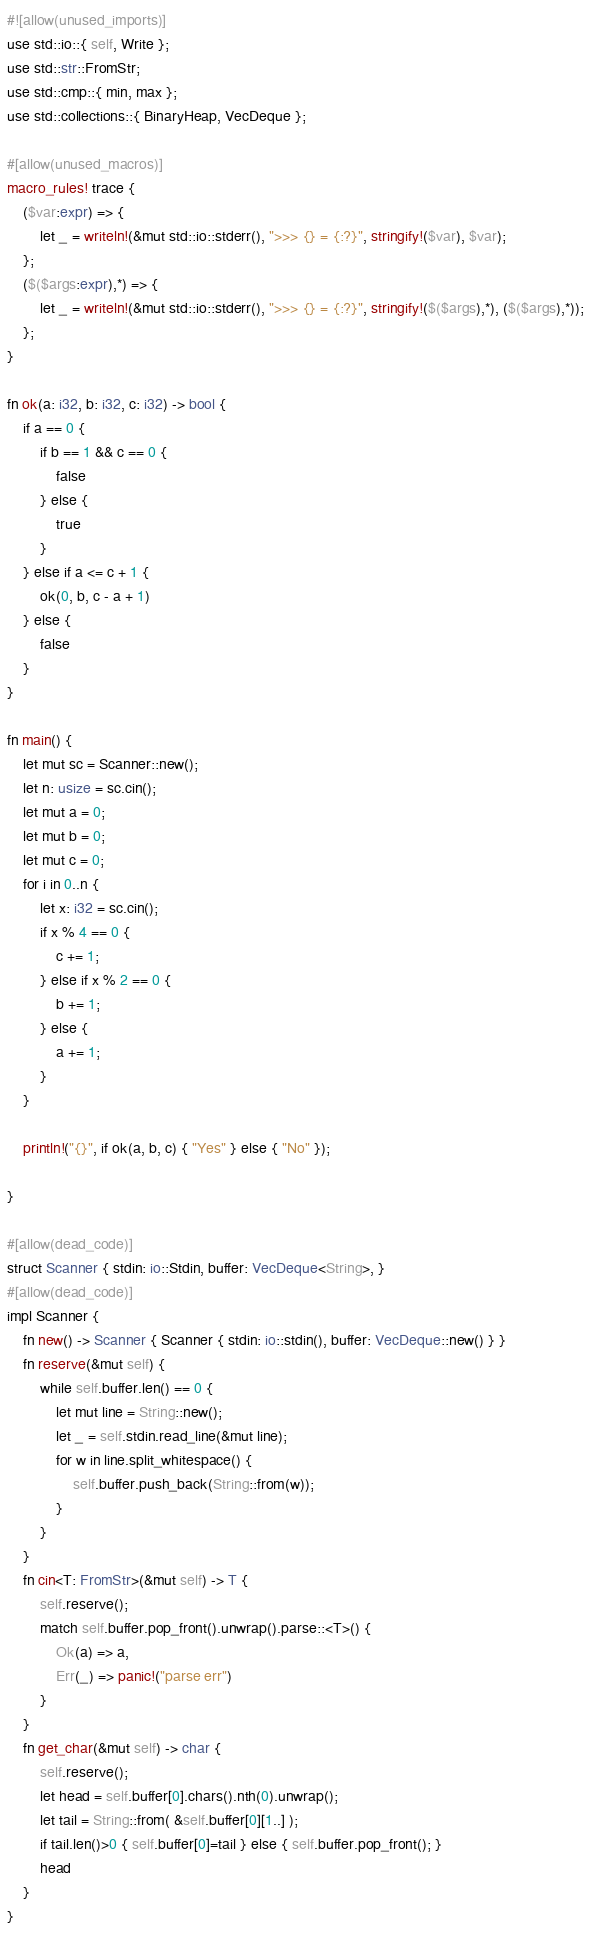Convert code to text. <code><loc_0><loc_0><loc_500><loc_500><_Rust_>#![allow(unused_imports)]
use std::io::{ self, Write };
use std::str::FromStr;
use std::cmp::{ min, max };
use std::collections::{ BinaryHeap, VecDeque };

#[allow(unused_macros)]
macro_rules! trace {
    ($var:expr) => {
        let _ = writeln!(&mut std::io::stderr(), ">>> {} = {:?}", stringify!($var), $var);
    };
    ($($args:expr),*) => {
        let _ = writeln!(&mut std::io::stderr(), ">>> {} = {:?}", stringify!($($args),*), ($($args),*));
    };
}

fn ok(a: i32, b: i32, c: i32) -> bool {
    if a == 0 {
        if b == 1 && c == 0 {
            false
        } else {
            true
        }
    } else if a <= c + 1 {
        ok(0, b, c - a + 1)
    } else {
        false
    }
}

fn main() {
    let mut sc = Scanner::new();
    let n: usize = sc.cin();
    let mut a = 0;
    let mut b = 0;
    let mut c = 0;
    for i in 0..n {
        let x: i32 = sc.cin();
        if x % 4 == 0 {
            c += 1;
        } else if x % 2 == 0 {
            b += 1;
        } else {
            a += 1;
        }
    }

    println!("{}", if ok(a, b, c) { "Yes" } else { "No" });

}

#[allow(dead_code)]
struct Scanner { stdin: io::Stdin, buffer: VecDeque<String>, }
#[allow(dead_code)]
impl Scanner {
    fn new() -> Scanner { Scanner { stdin: io::stdin(), buffer: VecDeque::new() } }
    fn reserve(&mut self) {
        while self.buffer.len() == 0 {
            let mut line = String::new();
            let _ = self.stdin.read_line(&mut line);
            for w in line.split_whitespace() {
                self.buffer.push_back(String::from(w));
            }
        }
    }
    fn cin<T: FromStr>(&mut self) -> T {
        self.reserve();
        match self.buffer.pop_front().unwrap().parse::<T>() {
            Ok(a) => a,
            Err(_) => panic!("parse err")
        }
    }
    fn get_char(&mut self) -> char {
        self.reserve();
        let head = self.buffer[0].chars().nth(0).unwrap();
        let tail = String::from( &self.buffer[0][1..] );
        if tail.len()>0 { self.buffer[0]=tail } else { self.buffer.pop_front(); }
        head
    }
}
</code> 